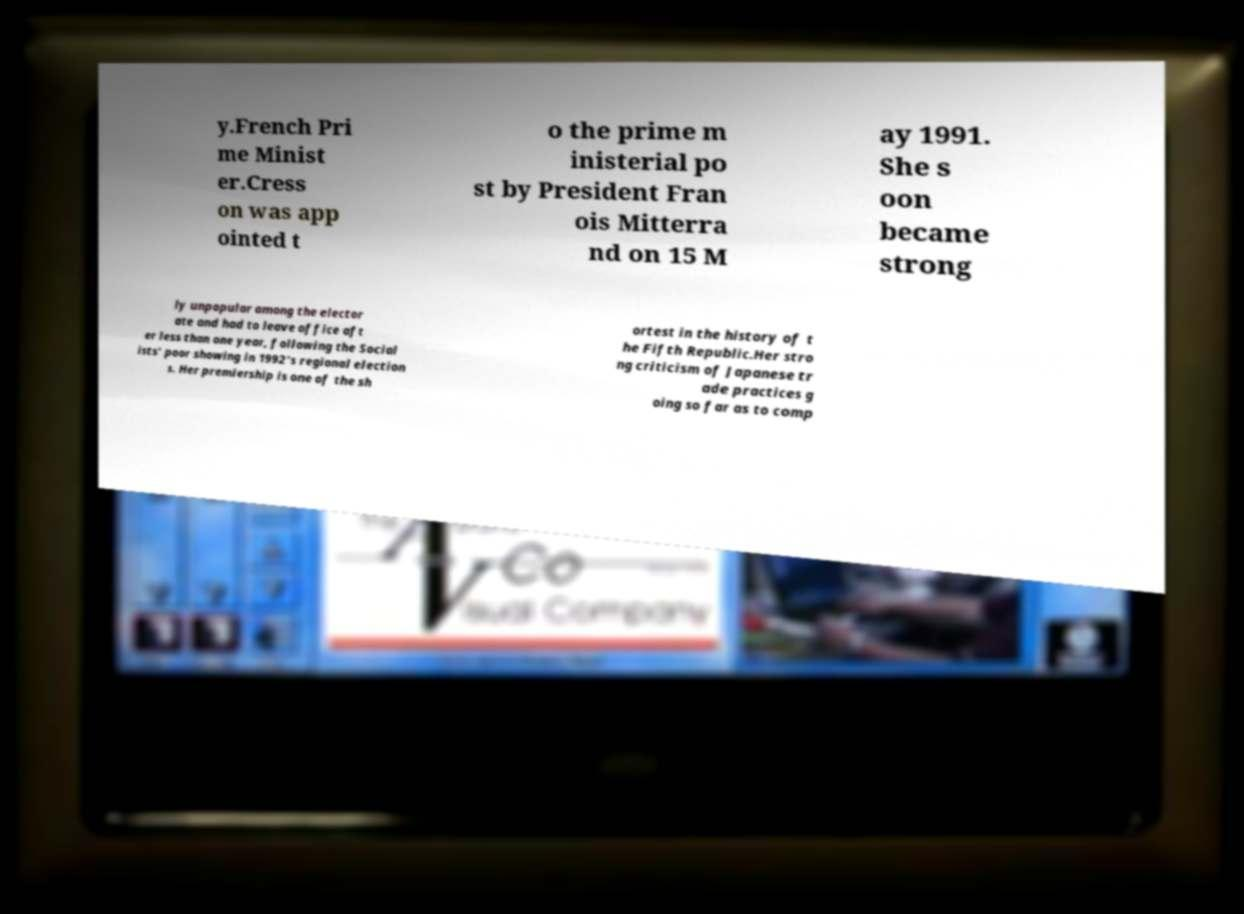Could you extract and type out the text from this image? y.French Pri me Minist er.Cress on was app ointed t o the prime m inisterial po st by President Fran ois Mitterra nd on 15 M ay 1991. She s oon became strong ly unpopular among the elector ate and had to leave office aft er less than one year, following the Social ists' poor showing in 1992's regional election s. Her premiership is one of the sh ortest in the history of t he Fifth Republic.Her stro ng criticism of Japanese tr ade practices g oing so far as to comp 